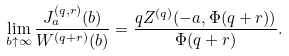Convert formula to latex. <formula><loc_0><loc_0><loc_500><loc_500>\lim _ { b \uparrow \infty } \frac { J _ { a } ^ { ( q , r ) } ( b ) } { W ^ { ( q + r ) } ( b ) } = \frac { q Z ^ { ( q ) } ( - a , \Phi ( q + r ) ) } { \Phi ( q + r ) } .</formula> 